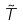Convert formula to latex. <formula><loc_0><loc_0><loc_500><loc_500>\tilde { T }</formula> 